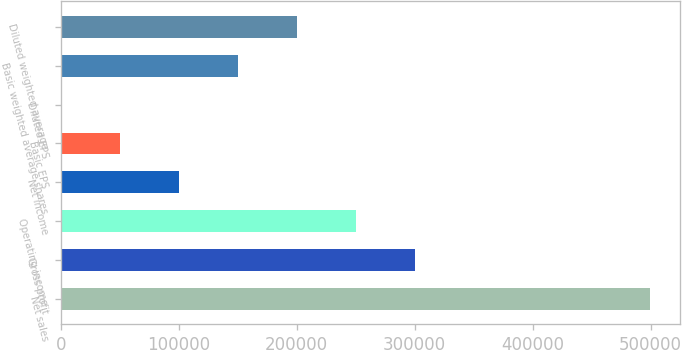Convert chart to OTSL. <chart><loc_0><loc_0><loc_500><loc_500><bar_chart><fcel>Net sales<fcel>Gross profit<fcel>Operating income<fcel>Net income<fcel>Basic EPS<fcel>Diluted EPS<fcel>Basic weighted average shares<fcel>Diluted weighted average<nl><fcel>499798<fcel>299879<fcel>249899<fcel>99960.3<fcel>49980.6<fcel>0.88<fcel>149940<fcel>199920<nl></chart> 